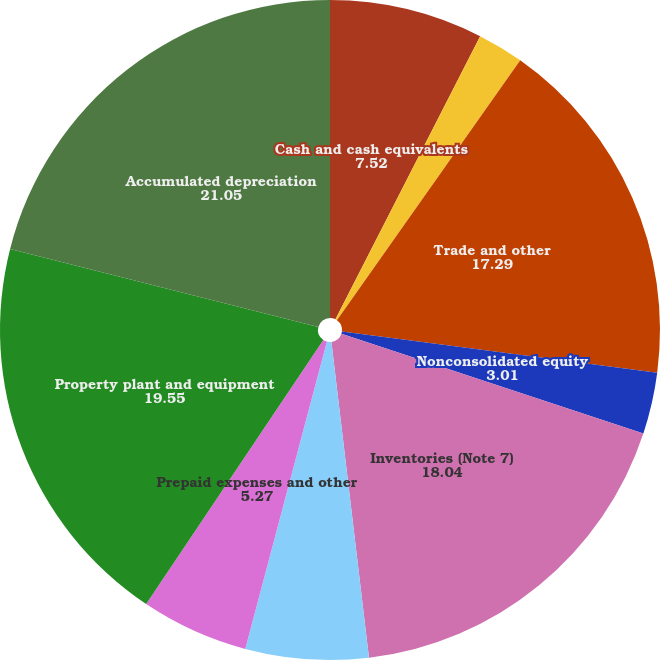Convert chart. <chart><loc_0><loc_0><loc_500><loc_500><pie_chart><fcel>Cash and cash equivalents<fcel>Marketable securities (Note 5)<fcel>Trade and other<fcel>Nonconsolidated equity<fcel>Inventories (Note 7)<fcel>Deferred income taxes (Note 4)<fcel>Prepaid expenses and other<fcel>Property plant and equipment<fcel>Accumulated depreciation<nl><fcel>7.52%<fcel>2.26%<fcel>17.29%<fcel>3.01%<fcel>18.04%<fcel>6.02%<fcel>5.27%<fcel>19.55%<fcel>21.05%<nl></chart> 